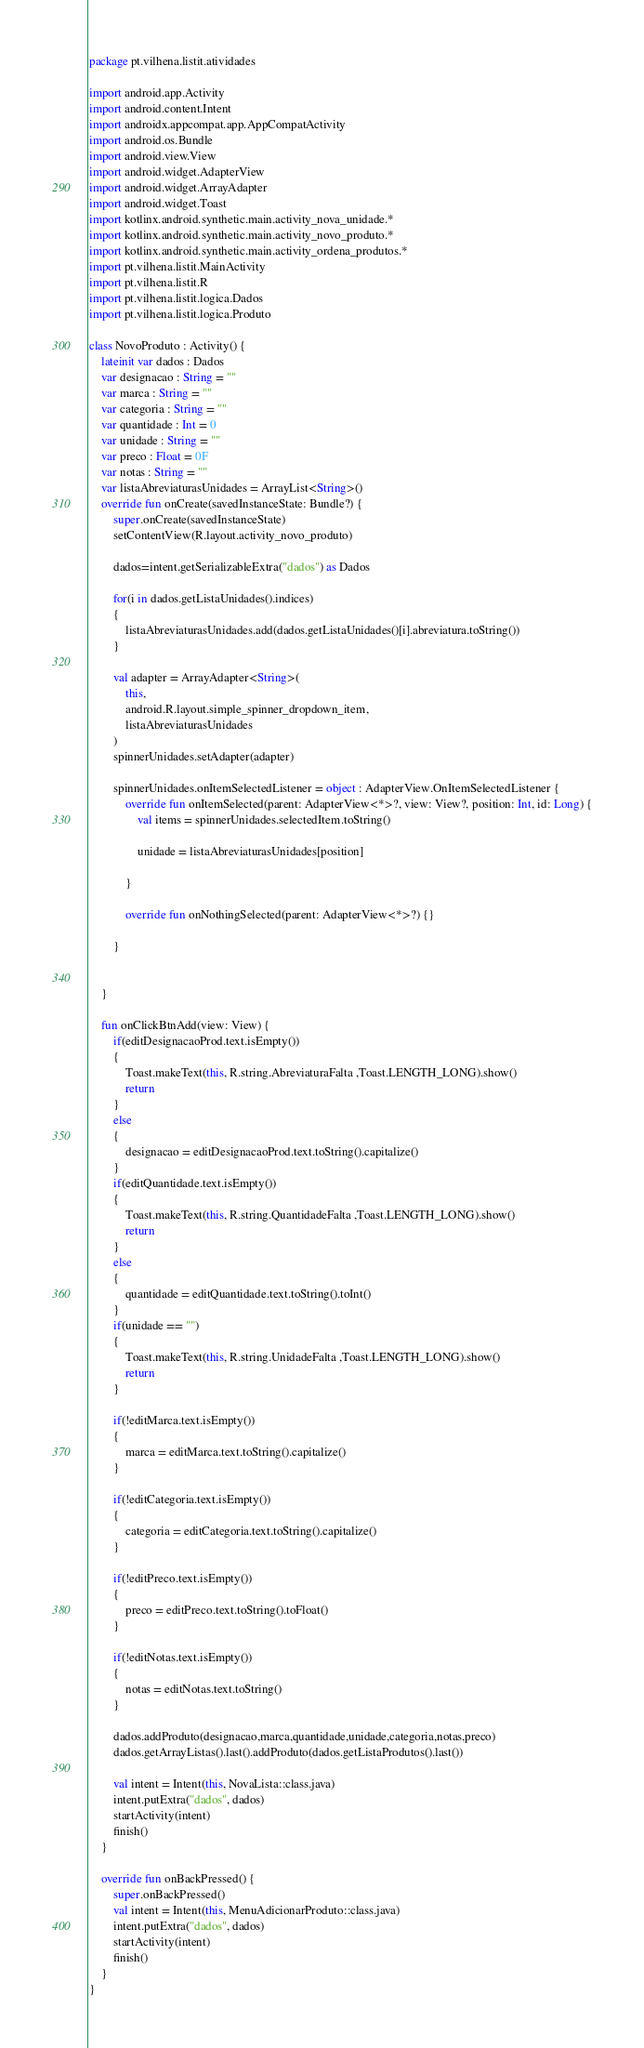<code> <loc_0><loc_0><loc_500><loc_500><_Kotlin_>package pt.vilhena.listit.atividades

import android.app.Activity
import android.content.Intent
import androidx.appcompat.app.AppCompatActivity
import android.os.Bundle
import android.view.View
import android.widget.AdapterView
import android.widget.ArrayAdapter
import android.widget.Toast
import kotlinx.android.synthetic.main.activity_nova_unidade.*
import kotlinx.android.synthetic.main.activity_novo_produto.*
import kotlinx.android.synthetic.main.activity_ordena_produtos.*
import pt.vilhena.listit.MainActivity
import pt.vilhena.listit.R
import pt.vilhena.listit.logica.Dados
import pt.vilhena.listit.logica.Produto

class NovoProduto : Activity() {
    lateinit var dados : Dados
    var designacao : String = ""
    var marca : String = ""
    var categoria : String = ""
    var quantidade : Int = 0
    var unidade : String = ""
    var preco : Float = 0F
    var notas : String = ""
    var listaAbreviaturasUnidades = ArrayList<String>()
    override fun onCreate(savedInstanceState: Bundle?) {
        super.onCreate(savedInstanceState)
        setContentView(R.layout.activity_novo_produto)

        dados=intent.getSerializableExtra("dados") as Dados

        for(i in dados.getListaUnidades().indices)
        {
            listaAbreviaturasUnidades.add(dados.getListaUnidades()[i].abreviatura.toString())
        }

        val adapter = ArrayAdapter<String>(
            this,
            android.R.layout.simple_spinner_dropdown_item,
            listaAbreviaturasUnidades
        )
        spinnerUnidades.setAdapter(adapter)

        spinnerUnidades.onItemSelectedListener = object : AdapterView.OnItemSelectedListener {
            override fun onItemSelected(parent: AdapterView<*>?, view: View?, position: Int, id: Long) {
                val items = spinnerUnidades.selectedItem.toString()

                unidade = listaAbreviaturasUnidades[position]

            }

            override fun onNothingSelected(parent: AdapterView<*>?) {}

        }


    }

    fun onClickBtnAdd(view: View) {
        if(editDesignacaoProd.text.isEmpty())
        {
            Toast.makeText(this, R.string.AbreviaturaFalta ,Toast.LENGTH_LONG).show()
            return
        }
        else
        {
            designacao = editDesignacaoProd.text.toString().capitalize()
        }
        if(editQuantidade.text.isEmpty())
        {
            Toast.makeText(this, R.string.QuantidadeFalta ,Toast.LENGTH_LONG).show()
            return
        }
        else
        {
            quantidade = editQuantidade.text.toString().toInt()
        }
        if(unidade == "")
        {
            Toast.makeText(this, R.string.UnidadeFalta ,Toast.LENGTH_LONG).show()
            return
        }

        if(!editMarca.text.isEmpty())
        {
            marca = editMarca.text.toString().capitalize()
        }

        if(!editCategoria.text.isEmpty())
        {
            categoria = editCategoria.text.toString().capitalize()
        }

        if(!editPreco.text.isEmpty())
        {
            preco = editPreco.text.toString().toFloat()
        }

        if(!editNotas.text.isEmpty())
        {
            notas = editNotas.text.toString()
        }

        dados.addProduto(designacao,marca,quantidade,unidade,categoria,notas,preco)
        dados.getArrayListas().last().addProduto(dados.getListaProdutos().last())

        val intent = Intent(this, NovaLista::class.java)
        intent.putExtra("dados", dados)
        startActivity(intent)
        finish()
    }

    override fun onBackPressed() {
        super.onBackPressed()
        val intent = Intent(this, MenuAdicionarProduto::class.java)
        intent.putExtra("dados", dados)
        startActivity(intent)
        finish()
    }
}</code> 